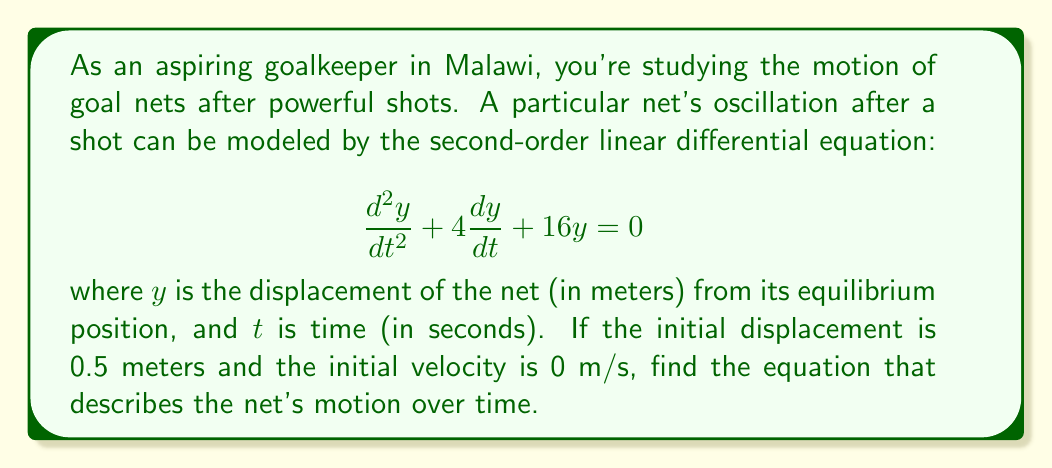Could you help me with this problem? To solve this problem, we'll follow these steps:

1) The general form of a second-order linear differential equation is:
   $$\frac{d^2y}{dt^2} + 2\zeta\omega_n\frac{dy}{dt} + \omega_n^2y = 0$$
   where $\zeta$ is the damping ratio and $\omega_n$ is the natural frequency.

2) Comparing our equation to the general form, we see that:
   $2\zeta\omega_n = 4$ and $\omega_n^2 = 16$

3) From $\omega_n^2 = 16$, we get $\omega_n = 4$ rad/s

4) Substituting this into $2\zeta\omega_n = 4$, we get:
   $2\zeta(4) = 4$
   $\zeta = 0.5$

5) Since $0 < \zeta < 1$, this is an underdamped system. The solution has the form:
   $$y(t) = e^{-\zeta\omega_n t}(A\cos(\omega_d t) + B\sin(\omega_d t))$$
   where $\omega_d = \omega_n\sqrt{1-\zeta^2}$

6) Calculate $\omega_d$:
   $$\omega_d = 4\sqrt{1-0.5^2} = 2\sqrt{3}$$ rad/s

7) Our solution now looks like:
   $$y(t) = e^{-2t}(A\cos(2\sqrt{3}t) + B\sin(2\sqrt{3}t))$$

8) Use initial conditions to find A and B:
   At $t=0$, $y(0) = 0.5$ and $y'(0) = 0$

   From $y(0) = 0.5$: $0.5 = A$
   
   From $y'(0) = 0$: $0 = -2A + 2\sqrt{3}B$
                     $B = \frac{1}{\sqrt{3}}$

9) Therefore, the final solution is:
   $$y(t) = e^{-2t}(0.5\cos(2\sqrt{3}t) + \frac{1}{\sqrt{3}}\sin(2\sqrt{3}t))$$
Answer: $$y(t) = e^{-2t}(0.5\cos(2\sqrt{3}t) + \frac{1}{\sqrt{3}}\sin(2\sqrt{3}t))$$ 